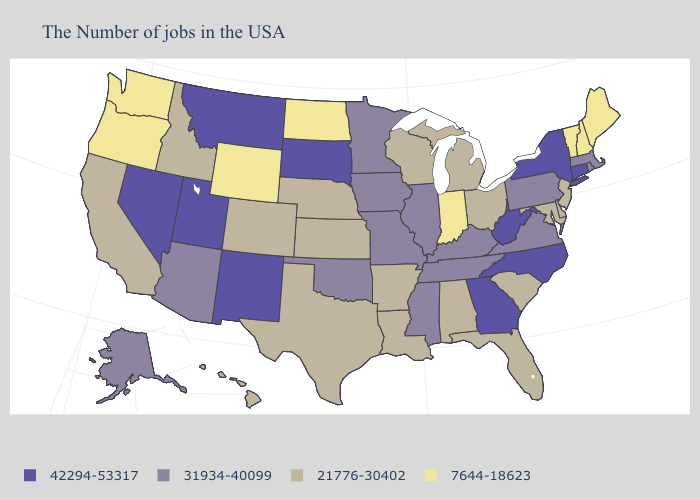Name the states that have a value in the range 42294-53317?
Be succinct. Connecticut, New York, North Carolina, West Virginia, Georgia, South Dakota, New Mexico, Utah, Montana, Nevada. Name the states that have a value in the range 42294-53317?
Short answer required. Connecticut, New York, North Carolina, West Virginia, Georgia, South Dakota, New Mexico, Utah, Montana, Nevada. What is the highest value in the South ?
Short answer required. 42294-53317. What is the value of Michigan?
Quick response, please. 21776-30402. Name the states that have a value in the range 7644-18623?
Concise answer only. Maine, New Hampshire, Vermont, Indiana, North Dakota, Wyoming, Washington, Oregon. What is the value of Indiana?
Write a very short answer. 7644-18623. What is the value of Oregon?
Concise answer only. 7644-18623. What is the lowest value in the South?
Answer briefly. 21776-30402. Does Vermont have the lowest value in the Northeast?
Write a very short answer. Yes. What is the highest value in states that border New Mexico?
Concise answer only. 42294-53317. Among the states that border Virginia , which have the lowest value?
Short answer required. Maryland. What is the value of Alabama?
Concise answer only. 21776-30402. What is the lowest value in the USA?
Give a very brief answer. 7644-18623. Is the legend a continuous bar?
Answer briefly. No. 